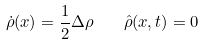<formula> <loc_0><loc_0><loc_500><loc_500>\dot { \rho } ( x ) = \frac { 1 } { 2 } \Delta \rho \quad { \hat { \rho } } ( x , t ) = 0</formula> 